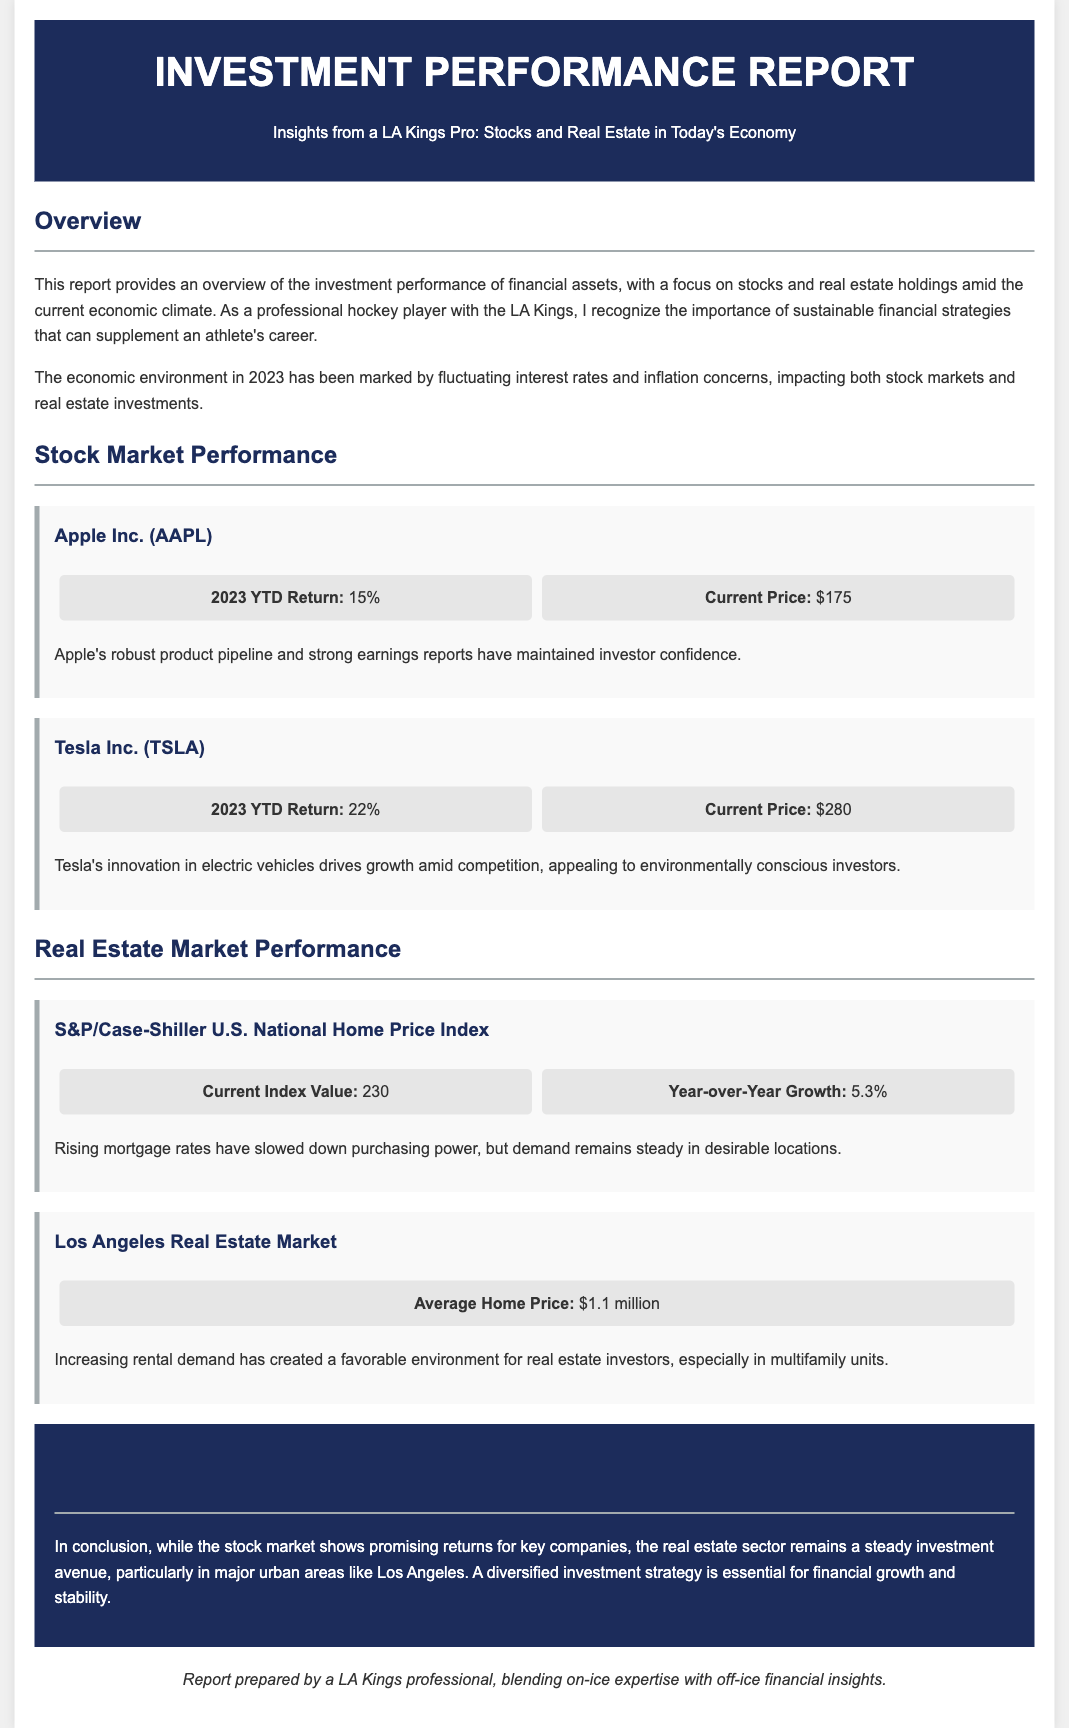what is the 2023 YTD return for Apple Inc.? The 2023 YTD return for Apple Inc. is provided in the document under the stock market performance section.
Answer: 15% what is the current price of Tesla Inc.? The current price of Tesla Inc. is listed in the performance data for Tesla in the stock market performance section.
Answer: $280 what is the average home price in the Los Angeles real estate market? The average home price is specified in the real estate market performance section focused on the Los Angeles area.
Answer: $1.1 million what is the current index value of the S&P/Case-Shiller U.S. National Home Price Index? The current index value is stated in the performance data for the S&P/Case-Shiller U.S. National Home Price Index in the real estate market performance section.
Answer: 230 what has contributed to Apple's investor confidence? The document mentions specific reasons for investor confidence in Apple's performance under the stock market performance section.
Answer: Robust product pipeline and strong earnings reports what is the year-over-year growth for the S&P/Case-Shiller Index? The year-over-year growth is included in the performance data for the S&P/Case-Shiller U.S. National Home Price Index.
Answer: 5.3% how does the real estate market in Los Angeles remain favorable for investors? The conclusion section provides insights into the current dynamics of the real estate market and factors influencing investor sentiment.
Answer: Increasing rental demand what is the focus of this investment performance report? The introduction outlines the main subjects covered in the report regarding various financial assets.
Answer: Stocks and real estate holdings what was a significant factor affecting the economic environment in 2023? The overview section identifies key elements of the economic climate that are influencing investment strategies.
Answer: Fluctuating interest rates and inflation concerns 